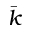Convert formula to latex. <formula><loc_0><loc_0><loc_500><loc_500>\bar { k }</formula> 